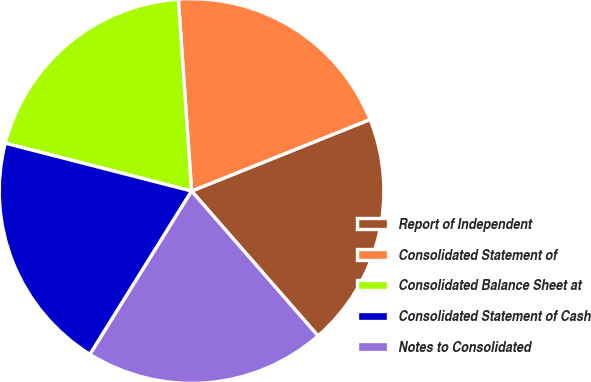Convert chart. <chart><loc_0><loc_0><loc_500><loc_500><pie_chart><fcel>Report of Independent<fcel>Consolidated Statement of<fcel>Consolidated Balance Sheet at<fcel>Consolidated Statement of Cash<fcel>Notes to Consolidated<nl><fcel>19.65%<fcel>20.03%<fcel>19.9%<fcel>20.15%<fcel>20.28%<nl></chart> 